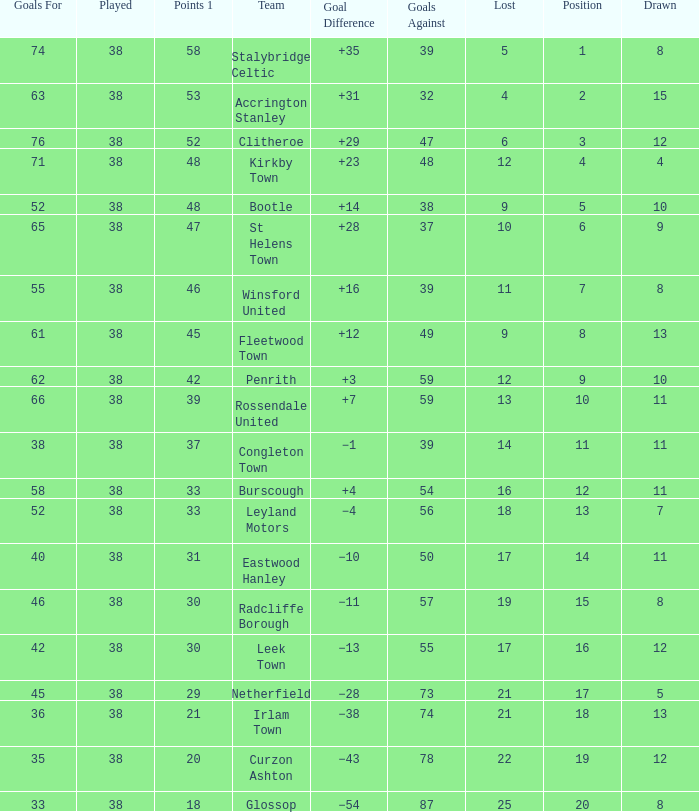What is the total number drawn with goals against less than 55, and a total of 14 losses? 1.0. Could you parse the entire table? {'header': ['Goals For', 'Played', 'Points 1', 'Team', 'Goal Difference', 'Goals Against', 'Lost', 'Position', 'Drawn'], 'rows': [['74', '38', '58', 'Stalybridge Celtic', '+35', '39', '5', '1', '8'], ['63', '38', '53', 'Accrington Stanley', '+31', '32', '4', '2', '15'], ['76', '38', '52', 'Clitheroe', '+29', '47', '6', '3', '12'], ['71', '38', '48', 'Kirkby Town', '+23', '48', '12', '4', '4'], ['52', '38', '48', 'Bootle', '+14', '38', '9', '5', '10'], ['65', '38', '47', 'St Helens Town', '+28', '37', '10', '6', '9'], ['55', '38', '46', 'Winsford United', '+16', '39', '11', '7', '8'], ['61', '38', '45', 'Fleetwood Town', '+12', '49', '9', '8', '13'], ['62', '38', '42', 'Penrith', '+3', '59', '12', '9', '10'], ['66', '38', '39', 'Rossendale United', '+7', '59', '13', '10', '11'], ['38', '38', '37', 'Congleton Town', '−1', '39', '14', '11', '11'], ['58', '38', '33', 'Burscough', '+4', '54', '16', '12', '11'], ['52', '38', '33', 'Leyland Motors', '−4', '56', '18', '13', '7'], ['40', '38', '31', 'Eastwood Hanley', '−10', '50', '17', '14', '11'], ['46', '38', '30', 'Radcliffe Borough', '−11', '57', '19', '15', '8'], ['42', '38', '30', 'Leek Town', '−13', '55', '17', '16', '12'], ['45', '38', '29', 'Netherfield', '−28', '73', '21', '17', '5'], ['36', '38', '21', 'Irlam Town', '−38', '74', '21', '18', '13'], ['35', '38', '20', 'Curzon Ashton', '−43', '78', '22', '19', '12'], ['33', '38', '18', 'Glossop', '−54', '87', '25', '20', '8']]} 